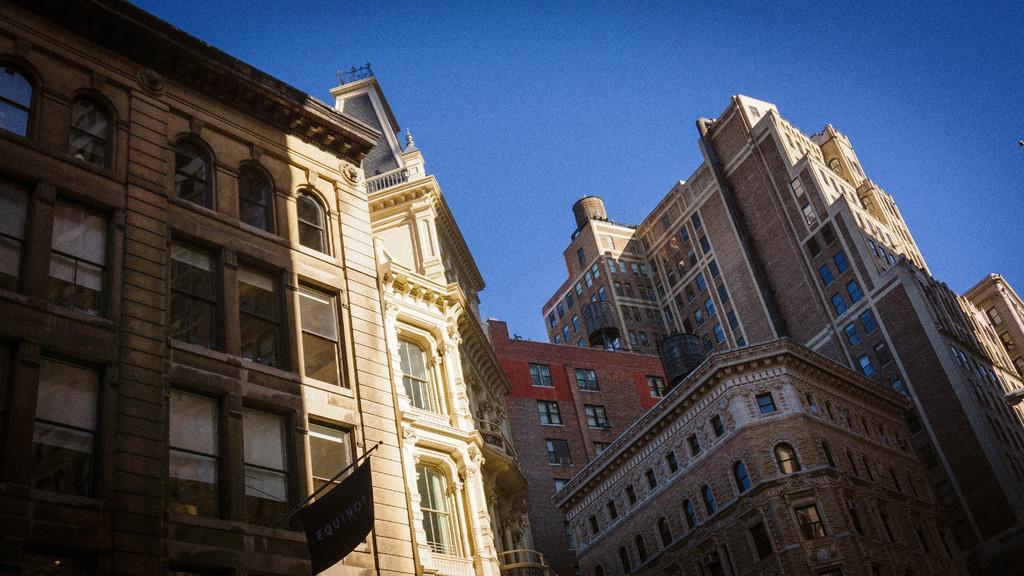How would you summarize this image in a sentence or two? In this image I can see few buildings, few windows of the buildings and a board. In the background I can see the sky. 